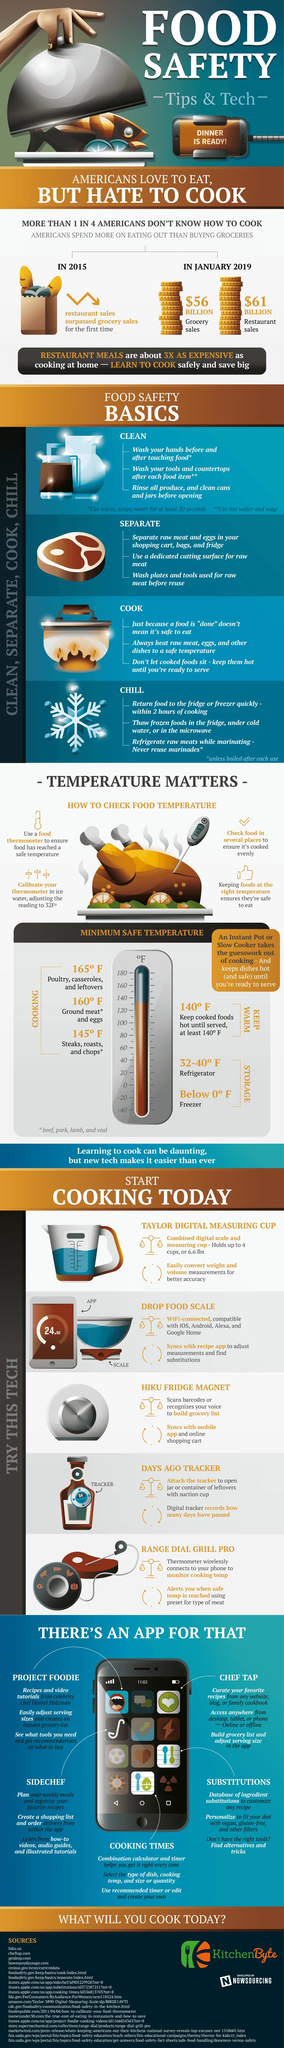Highlight a few significant elements in this photo. The minimum safe temperature for cooking poultry is 165 degrees Fahrenheit, which ensures that the meat is thoroughly cooked and safe to eat. In January 2019, the restaurant industry in the United States generated a total of approximately $61 billion in sales. In January 2019, the total sales generated by grocery stores in the United States amounted to approximately $56 BILLION. The minimum safe temperature for cooking steaks is 145 degrees Fahrenheit. 